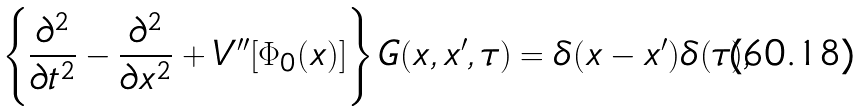<formula> <loc_0><loc_0><loc_500><loc_500>\left \{ \frac { \partial ^ { 2 } } { \partial t ^ { 2 } } - \frac { \partial ^ { 2 } } { \partial x ^ { 2 } } + V ^ { \prime \prime } [ \Phi _ { 0 } ( x ) ] \right \} G ( x , x ^ { \prime } , \tau ) = \delta ( x - x ^ { \prime } ) \delta ( \tau ) ,</formula> 